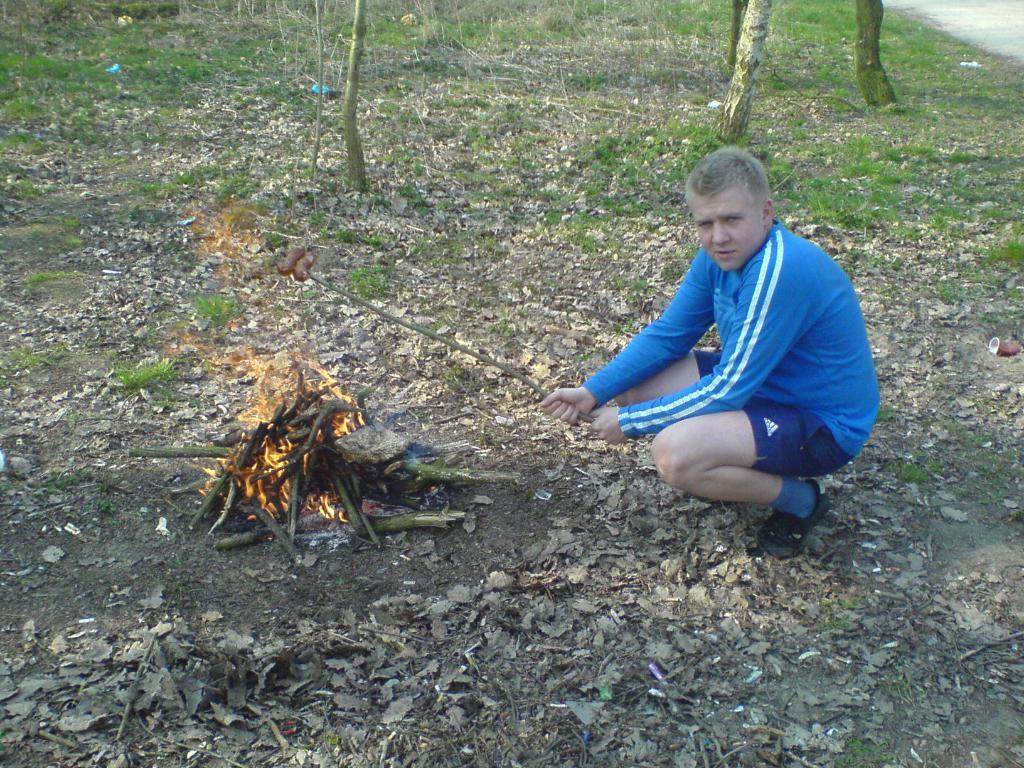What is the man in the image doing? The man is sitting in a squat position. What is the man holding in the image? The man is holding a stick with food. What can be seen in the image besides the man and the stick with food? There are sticks, fire, leaves, plants, grass, and a tree trunk visible in the image. What language is the man speaking in the image? There is no indication of the man speaking in the image, so it is not possible to determine the language. --- Facts: 1. There is a person standing on a bridge. 2. The bridge is over a river. 3. The river has water flowing. 4. There are trees on both sides of the river. 5. The sky is visible in the image. Absurd Topics: bicycle, parrot, umbrella Conversation: What is the person in the image doing? The person is standing on a bridge. What is the bridge positioned over in the image? The bridge is over a river. What can be observed about the river in the image? The river has water flowing. What type of vegetation is present near the river in the image? There are trees on both sides of the river. What is visible in the background of the image? The sky is visible in the image. Reasoning: Let's think step by step in order to produce the conversation. We start by identifying the main subject in the image, which is the person standing on a bridge. Then, we describe the bridge's location, which is over a river. Next, we expand the conversation to include details about the river, such as the water flowing. We also mention the presence of trees on both sides of the river and the visibility of the sky in the background. Each question is designed to elicit a specific detail about the image that is known from the provided facts. Absurd Question/Answer: What color is the parrot perched on the bicycle in the image? There is no bicycle or parrot present in the image. 